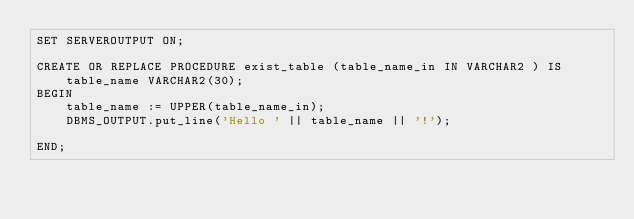<code> <loc_0><loc_0><loc_500><loc_500><_SQL_>SET SERVEROUTPUT ON; 

CREATE OR REPLACE PROCEDURE exist_table (table_name_in IN VARCHAR2 ) IS
    table_name VARCHAR2(30);
BEGIN
    table_name := UPPER(table_name_in);
    DBMS_OUTPUT.put_line('Hello ' || table_name || '!');
    
END;</code> 